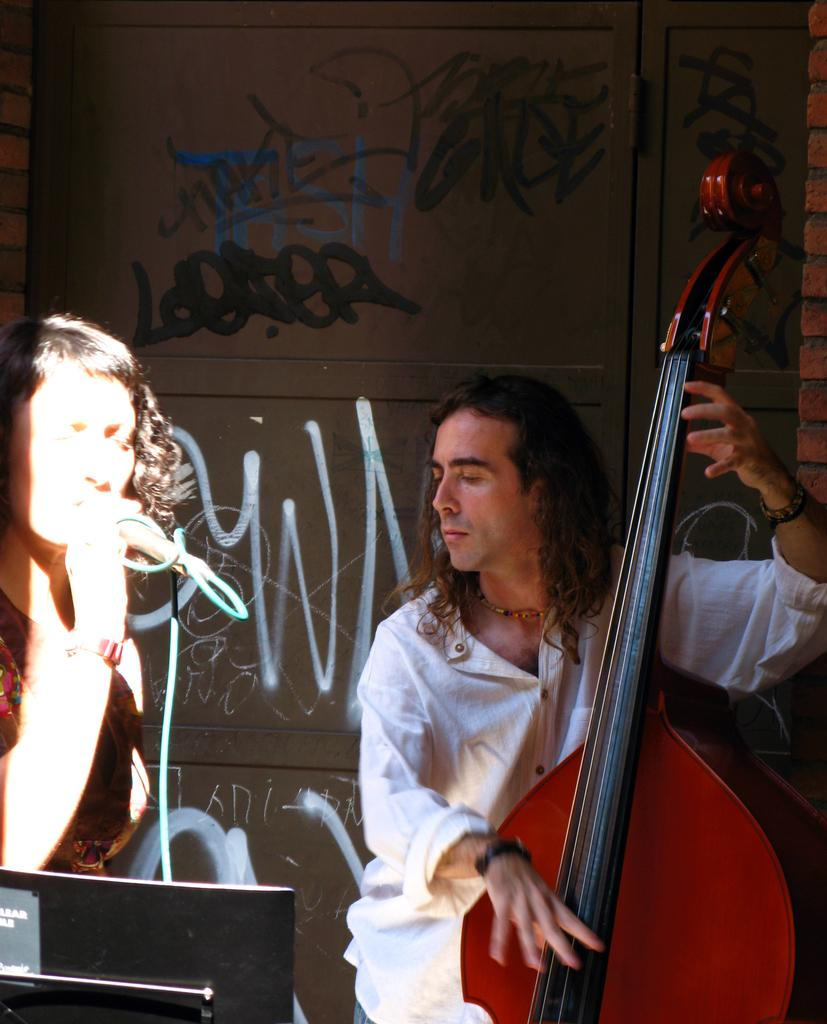What is the man in the image doing? The man is playing a musical instrument in the image. What is the woman in the image doing? The woman is singing a song in the image. How is the woman amplifying her voice while singing? The woman is using a microphone (mike) while singing. What type of food is being prepared on the love flame in the image? There is no food, love, or flame present in the image; it features a man playing a musical instrument and a woman singing with a microphone. 